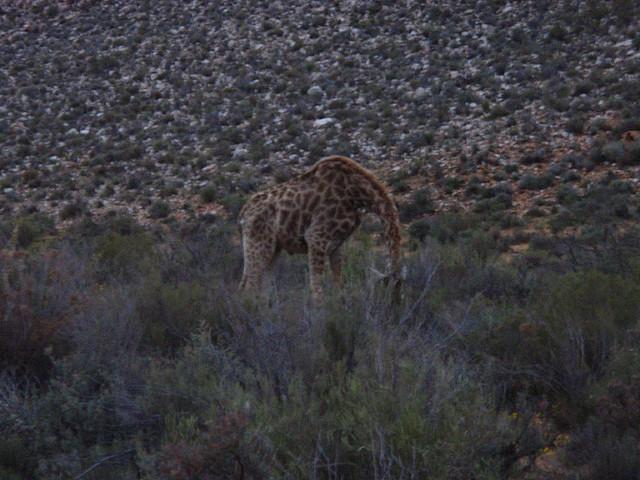How many people are in this picture?
Give a very brief answer. 0. 